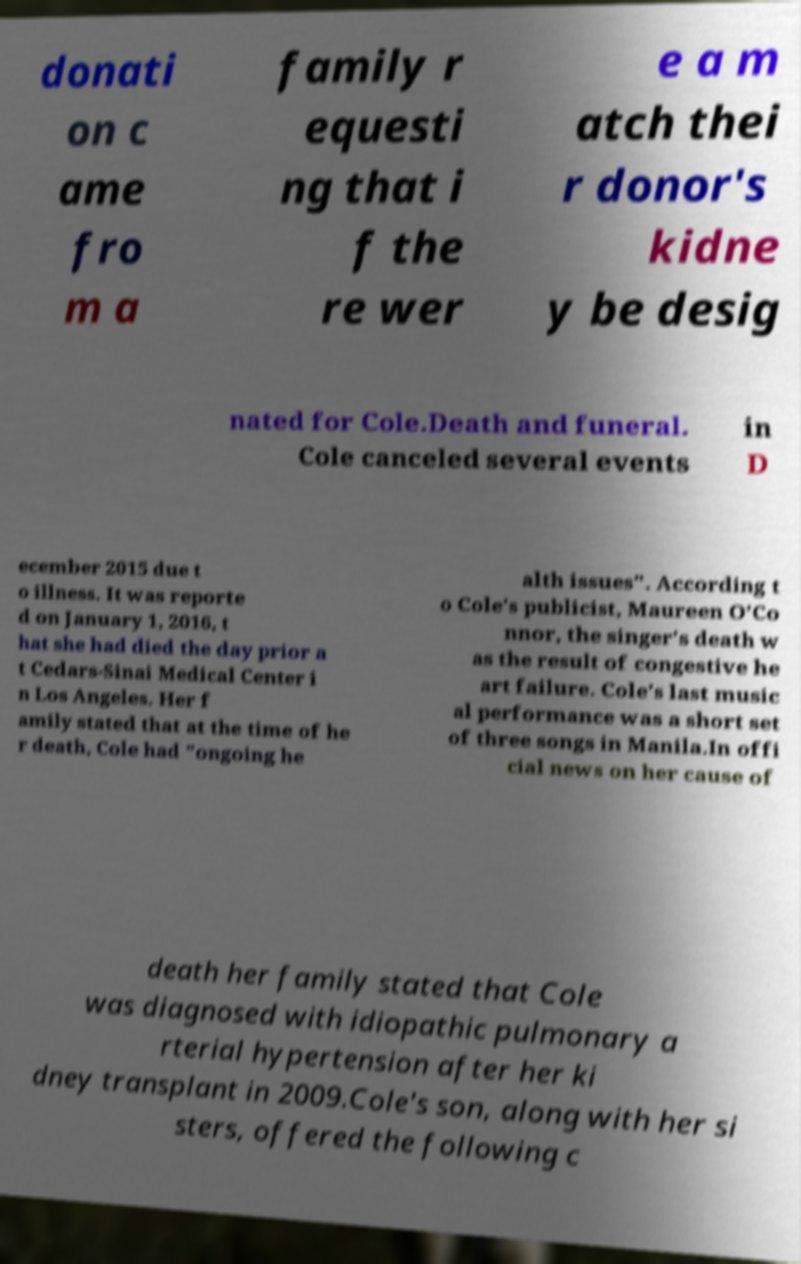Can you read and provide the text displayed in the image?This photo seems to have some interesting text. Can you extract and type it out for me? donati on c ame fro m a family r equesti ng that i f the re wer e a m atch thei r donor's kidne y be desig nated for Cole.Death and funeral. Cole canceled several events in D ecember 2015 due t o illness. It was reporte d on January 1, 2016, t hat she had died the day prior a t Cedars-Sinai Medical Center i n Los Angeles. Her f amily stated that at the time of he r death, Cole had "ongoing he alth issues". According t o Cole's publicist, Maureen O'Co nnor, the singer's death w as the result of congestive he art failure. Cole's last music al performance was a short set of three songs in Manila.In offi cial news on her cause of death her family stated that Cole was diagnosed with idiopathic pulmonary a rterial hypertension after her ki dney transplant in 2009.Cole's son, along with her si sters, offered the following c 